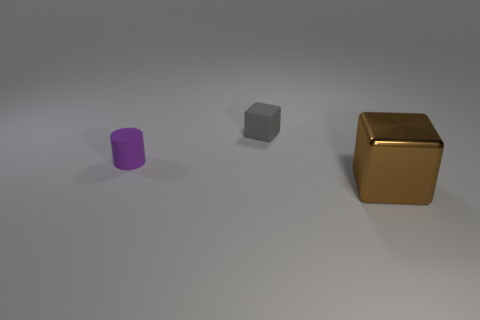How many other things are there of the same color as the cylinder?
Ensure brevity in your answer.  0. There is a brown metal cube; does it have the same size as the block that is behind the big shiny cube?
Provide a short and direct response. No. There is a cube that is to the right of the rubber block; is it the same size as the gray matte thing?
Ensure brevity in your answer.  No. What number of other objects are the same material as the tiny purple cylinder?
Your answer should be compact. 1. Is the number of tiny matte cubes to the right of the small gray matte object the same as the number of tiny gray objects that are behind the brown block?
Offer a terse response. No. There is a tiny rubber cylinder that is on the left side of the block on the left side of the cube to the right of the small gray matte thing; what color is it?
Your answer should be compact. Purple. There is a tiny matte object behind the purple object; what shape is it?
Ensure brevity in your answer.  Cube. The tiny purple object that is made of the same material as the tiny gray block is what shape?
Offer a terse response. Cylinder. Are there any other things that have the same shape as the gray thing?
Make the answer very short. Yes. There is a metallic cube; how many matte cylinders are on the right side of it?
Keep it short and to the point. 0. 